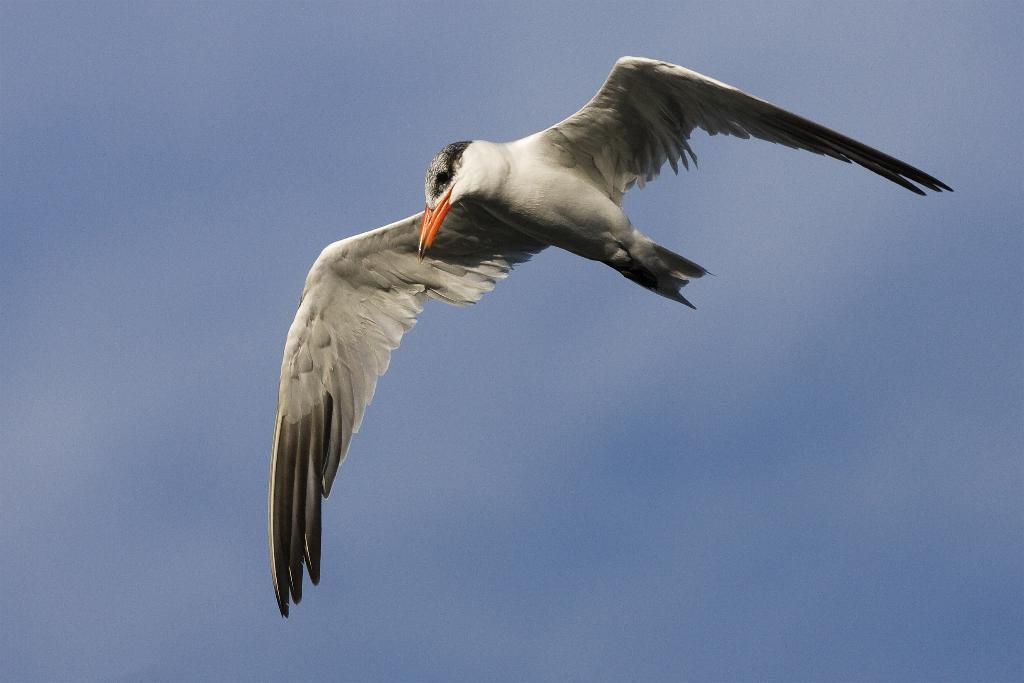What type of animal can be seen in the image? There is a bird in the image. What is the bird doing in the image? The bird is flying in the sky. Where is the bird located in the image? The bird is in the center of the image. How many sons does the bird have in the image? There is no mention of sons or any other family members in the image; it only features a bird flying in the sky. 